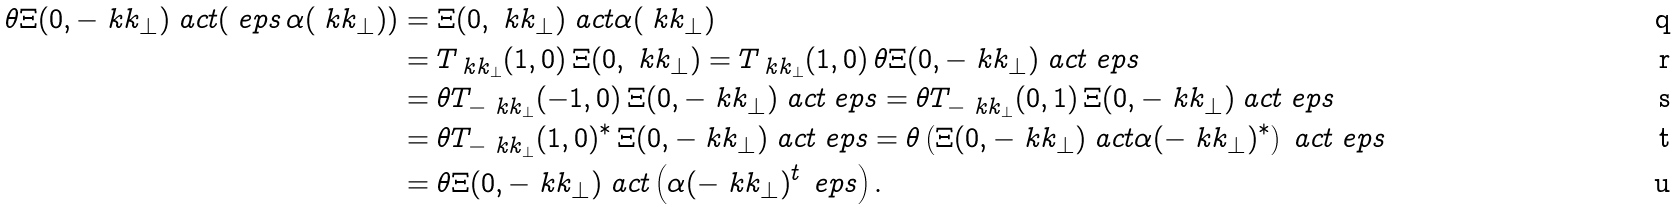Convert formula to latex. <formula><loc_0><loc_0><loc_500><loc_500>\theta \Xi ( 0 , - \ k k _ { \perp } ) \ a c t ( \ e p s \, \alpha ( \ k k _ { \perp } ) ) & = \Xi ( 0 , \ k k _ { \perp } ) \ a c t \alpha ( \ k k _ { \perp } ) \\ & = T _ { \ k k _ { \perp } } ( 1 , 0 ) \, \Xi ( 0 , \ k k _ { \perp } ) = T _ { \ k k _ { \perp } } ( 1 , 0 ) \, \theta \Xi ( 0 , - \ k k _ { \perp } ) \ a c t \ e p s \\ & = \theta T _ { - \ k k _ { \perp } } ( - 1 , 0 ) \, \Xi ( 0 , - \ k k _ { \perp } ) \ a c t \ e p s = \theta T _ { - \ k k _ { \perp } } ( 0 , 1 ) \, \Xi ( 0 , - \ k k _ { \perp } ) \ a c t \ e p s \\ & = \theta T _ { - \ k k _ { \perp } } ( 1 , 0 ) ^ { * } \, \Xi ( 0 , - \ k k _ { \perp } ) \ a c t \ e p s = \theta \left ( \Xi ( 0 , - \ k k _ { \perp } ) \ a c t \alpha ( - \ k k _ { \perp } ) ^ { * } \right ) \ a c t \ e p s \\ & = \theta \Xi ( 0 , - \ k k _ { \perp } ) \ a c t \left ( \alpha ( - \ k k _ { \perp } ) ^ { t } \, \ e p s \right ) .</formula> 